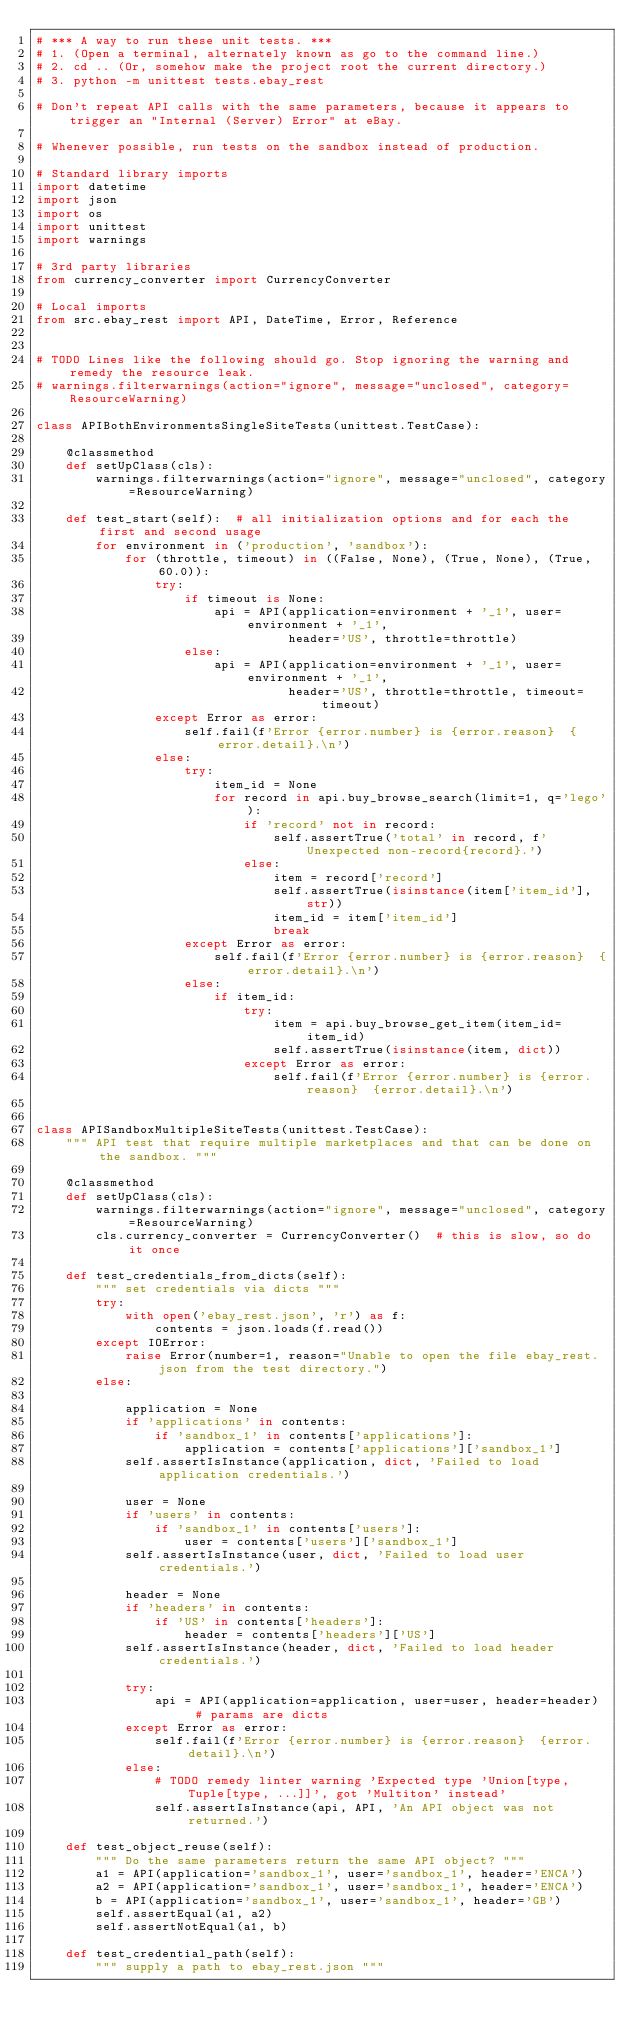<code> <loc_0><loc_0><loc_500><loc_500><_Python_># *** A way to run these unit tests. ***
# 1. (Open a terminal, alternately known as go to the command line.)
# 2. cd .. (Or, somehow make the project root the current directory.)
# 3. python -m unittest tests.ebay_rest

# Don't repeat API calls with the same parameters, because it appears to trigger an "Internal (Server) Error" at eBay.

# Whenever possible, run tests on the sandbox instead of production.

# Standard library imports
import datetime
import json
import os
import unittest
import warnings

# 3rd party libraries
from currency_converter import CurrencyConverter

# Local imports
from src.ebay_rest import API, DateTime, Error, Reference


# TODO Lines like the following should go. Stop ignoring the warning and remedy the resource leak.
# warnings.filterwarnings(action="ignore", message="unclosed", category=ResourceWarning)

class APIBothEnvironmentsSingleSiteTests(unittest.TestCase):

    @classmethod
    def setUpClass(cls):
        warnings.filterwarnings(action="ignore", message="unclosed", category=ResourceWarning)

    def test_start(self):  # all initialization options and for each the first and second usage
        for environment in ('production', 'sandbox'):
            for (throttle, timeout) in ((False, None), (True, None), (True, 60.0)):
                try:
                    if timeout is None:
                        api = API(application=environment + '_1', user=environment + '_1',
                                  header='US', throttle=throttle)
                    else:
                        api = API(application=environment + '_1', user=environment + '_1',
                                  header='US', throttle=throttle, timeout=timeout)
                except Error as error:
                    self.fail(f'Error {error.number} is {error.reason}  {error.detail}.\n')
                else:
                    try:
                        item_id = None
                        for record in api.buy_browse_search(limit=1, q='lego'):
                            if 'record' not in record:
                                self.assertTrue('total' in record, f'Unexpected non-record{record}.')
                            else:
                                item = record['record']
                                self.assertTrue(isinstance(item['item_id'], str))
                                item_id = item['item_id']
                                break
                    except Error as error:
                        self.fail(f'Error {error.number} is {error.reason}  {error.detail}.\n')
                    else:
                        if item_id:
                            try:
                                item = api.buy_browse_get_item(item_id=item_id)
                                self.assertTrue(isinstance(item, dict))
                            except Error as error:
                                self.fail(f'Error {error.number} is {error.reason}  {error.detail}.\n')


class APISandboxMultipleSiteTests(unittest.TestCase):
    """ API test that require multiple marketplaces and that can be done on the sandbox. """

    @classmethod
    def setUpClass(cls):
        warnings.filterwarnings(action="ignore", message="unclosed", category=ResourceWarning)
        cls.currency_converter = CurrencyConverter()  # this is slow, so do it once

    def test_credentials_from_dicts(self):
        """ set credentials via dicts """
        try:
            with open('ebay_rest.json', 'r') as f:
                contents = json.loads(f.read())
        except IOError:
            raise Error(number=1, reason="Unable to open the file ebay_rest.json from the test directory.")
        else:

            application = None
            if 'applications' in contents:
                if 'sandbox_1' in contents['applications']:
                    application = contents['applications']['sandbox_1']
            self.assertIsInstance(application, dict, 'Failed to load application credentials.')

            user = None
            if 'users' in contents:
                if 'sandbox_1' in contents['users']:
                    user = contents['users']['sandbox_1']
            self.assertIsInstance(user, dict, 'Failed to load user credentials.')

            header = None
            if 'headers' in contents:
                if 'US' in contents['headers']:
                    header = contents['headers']['US']
            self.assertIsInstance(header, dict, 'Failed to load header credentials.')

            try:
                api = API(application=application, user=user, header=header)  # params are dicts
            except Error as error:
                self.fail(f'Error {error.number} is {error.reason}  {error.detail}.\n')
            else:
                # TODO remedy linter warning 'Expected type 'Union[type, Tuple[type, ...]]', got 'Multiton' instead'
                self.assertIsInstance(api, API, 'An API object was not returned.')

    def test_object_reuse(self):
        """ Do the same parameters return the same API object? """
        a1 = API(application='sandbox_1', user='sandbox_1', header='ENCA')
        a2 = API(application='sandbox_1', user='sandbox_1', header='ENCA')
        b = API(application='sandbox_1', user='sandbox_1', header='GB')
        self.assertEqual(a1, a2)
        self.assertNotEqual(a1, b)

    def test_credential_path(self):
        """ supply a path to ebay_rest.json """</code> 